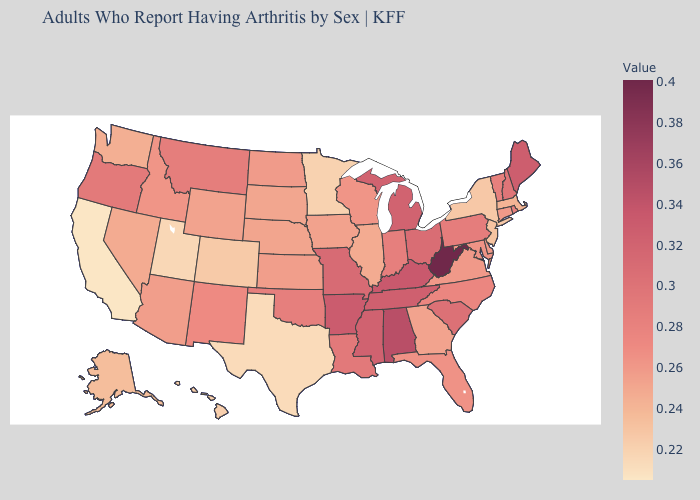Which states have the lowest value in the USA?
Answer briefly. California. Which states have the lowest value in the South?
Concise answer only. Texas. Does New Hampshire have a higher value than Kentucky?
Write a very short answer. No. Does Georgia have a higher value than Utah?
Answer briefly. Yes. Which states hav the highest value in the Northeast?
Answer briefly. Maine. Which states have the lowest value in the USA?
Be succinct. California. Does Maryland have a lower value than Ohio?
Quick response, please. Yes. Does Minnesota have the highest value in the USA?
Be succinct. No. 